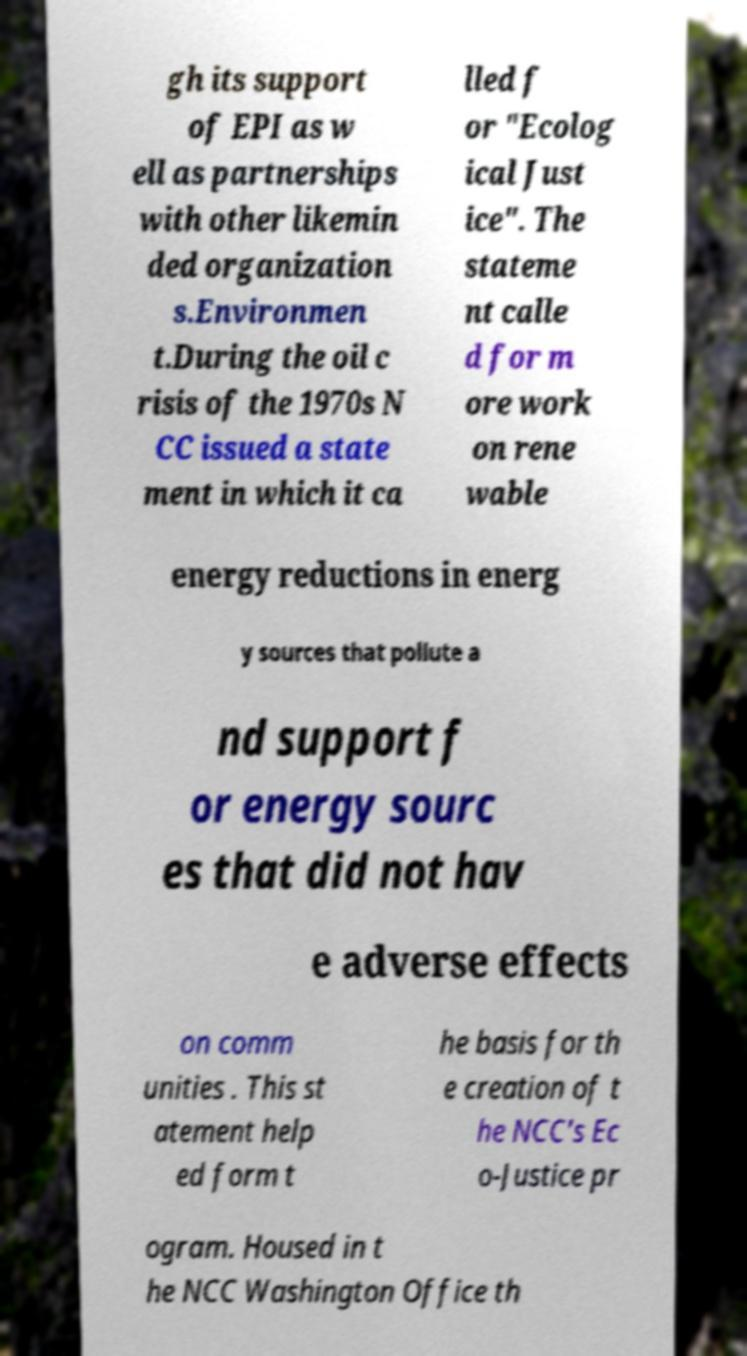Could you extract and type out the text from this image? gh its support of EPI as w ell as partnerships with other likemin ded organization s.Environmen t.During the oil c risis of the 1970s N CC issued a state ment in which it ca lled f or "Ecolog ical Just ice". The stateme nt calle d for m ore work on rene wable energy reductions in energ y sources that pollute a nd support f or energy sourc es that did not hav e adverse effects on comm unities . This st atement help ed form t he basis for th e creation of t he NCC's Ec o-Justice pr ogram. Housed in t he NCC Washington Office th 